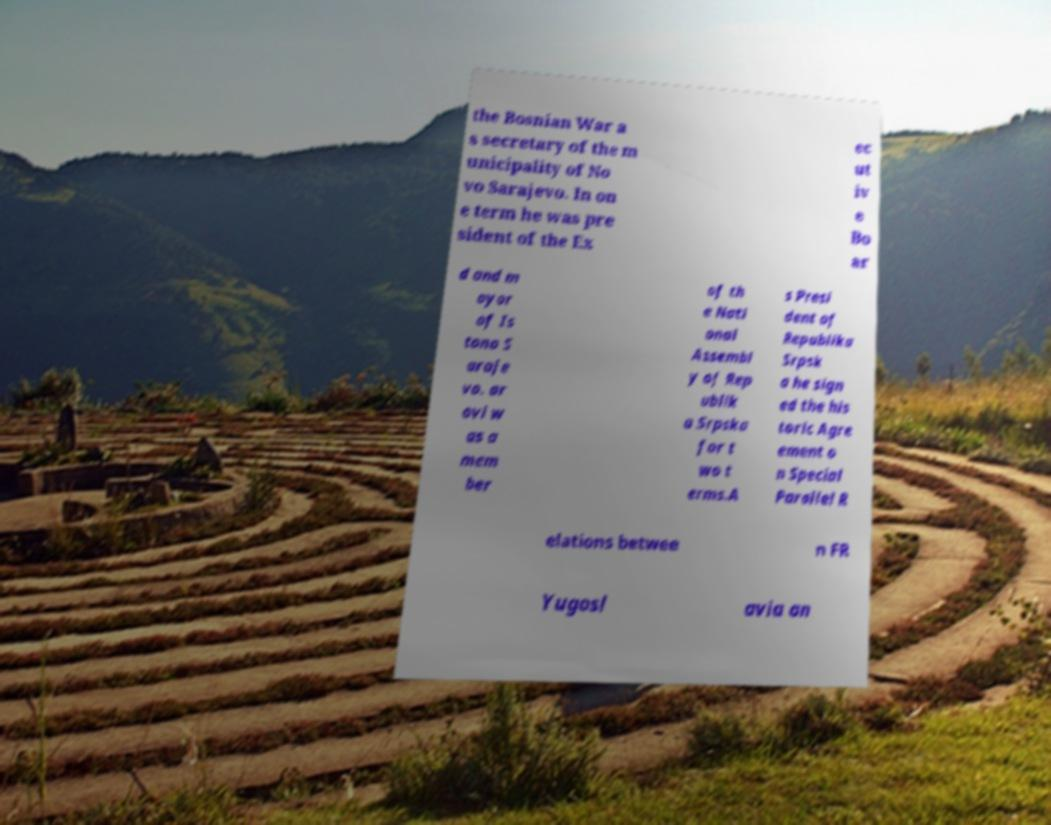Could you extract and type out the text from this image? the Bosnian War a s secretary of the m unicipality of No vo Sarajevo. In on e term he was pre sident of the Ex ec ut iv e Bo ar d and m ayor of Is tono S araje vo. ar ovi w as a mem ber of th e Nati onal Assembl y of Rep ublik a Srpska for t wo t erms.A s Presi dent of Republika Srpsk a he sign ed the his toric Agre ement o n Special Parallel R elations betwee n FR Yugosl avia an 